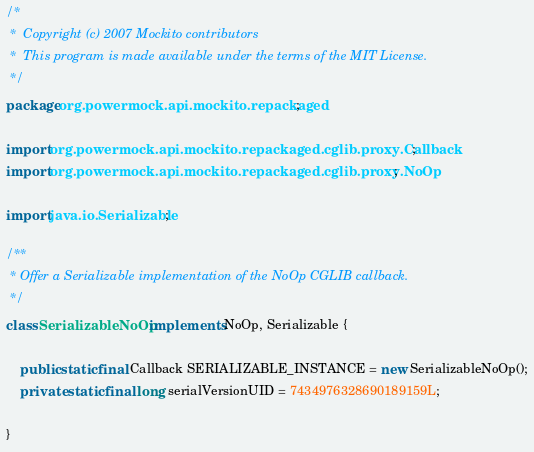<code> <loc_0><loc_0><loc_500><loc_500><_Java_>/*
 *  Copyright (c) 2007 Mockito contributors
 *  This program is made available under the terms of the MIT License.
 */
package org.powermock.api.mockito.repackaged;

import org.powermock.api.mockito.repackaged.cglib.proxy.Callback;
import org.powermock.api.mockito.repackaged.cglib.proxy.NoOp;

import java.io.Serializable;

/**
 * Offer a Serializable implementation of the NoOp CGLIB callback.
 */
class SerializableNoOp implements NoOp, Serializable {

    public static final Callback SERIALIZABLE_INSTANCE = new SerializableNoOp();
    private static final long serialVersionUID = 7434976328690189159L;

}</code> 